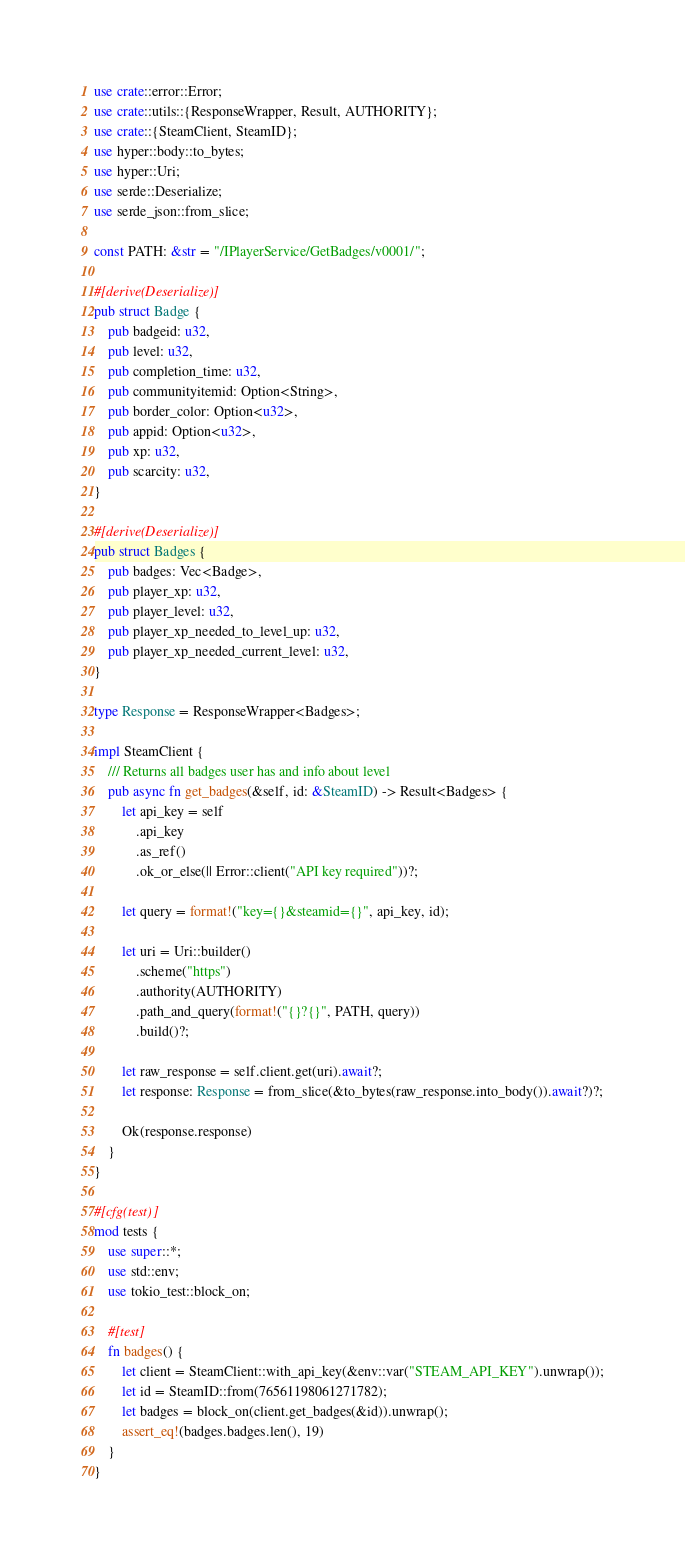Convert code to text. <code><loc_0><loc_0><loc_500><loc_500><_Rust_>use crate::error::Error;
use crate::utils::{ResponseWrapper, Result, AUTHORITY};
use crate::{SteamClient, SteamID};
use hyper::body::to_bytes;
use hyper::Uri;
use serde::Deserialize;
use serde_json::from_slice;

const PATH: &str = "/IPlayerService/GetBadges/v0001/";

#[derive(Deserialize)]
pub struct Badge {
    pub badgeid: u32,
    pub level: u32,
    pub completion_time: u32,
    pub communityitemid: Option<String>,
    pub border_color: Option<u32>,
    pub appid: Option<u32>,
    pub xp: u32,
    pub scarcity: u32,
}

#[derive(Deserialize)]
pub struct Badges {
    pub badges: Vec<Badge>,
    pub player_xp: u32,
    pub player_level: u32,
    pub player_xp_needed_to_level_up: u32,
    pub player_xp_needed_current_level: u32,
}

type Response = ResponseWrapper<Badges>;

impl SteamClient {
    /// Returns all badges user has and info about level
    pub async fn get_badges(&self, id: &SteamID) -> Result<Badges> {
        let api_key = self
            .api_key
            .as_ref()
            .ok_or_else(|| Error::client("API key required"))?;

        let query = format!("key={}&steamid={}", api_key, id);

        let uri = Uri::builder()
            .scheme("https")
            .authority(AUTHORITY)
            .path_and_query(format!("{}?{}", PATH, query))
            .build()?;

        let raw_response = self.client.get(uri).await?;
        let response: Response = from_slice(&to_bytes(raw_response.into_body()).await?)?;

        Ok(response.response)
    }
}

#[cfg(test)]
mod tests {
    use super::*;
    use std::env;
    use tokio_test::block_on;

    #[test]
    fn badges() {
        let client = SteamClient::with_api_key(&env::var("STEAM_API_KEY").unwrap());
        let id = SteamID::from(76561198061271782);
        let badges = block_on(client.get_badges(&id)).unwrap();
        assert_eq!(badges.badges.len(), 19)
    }
}
</code> 